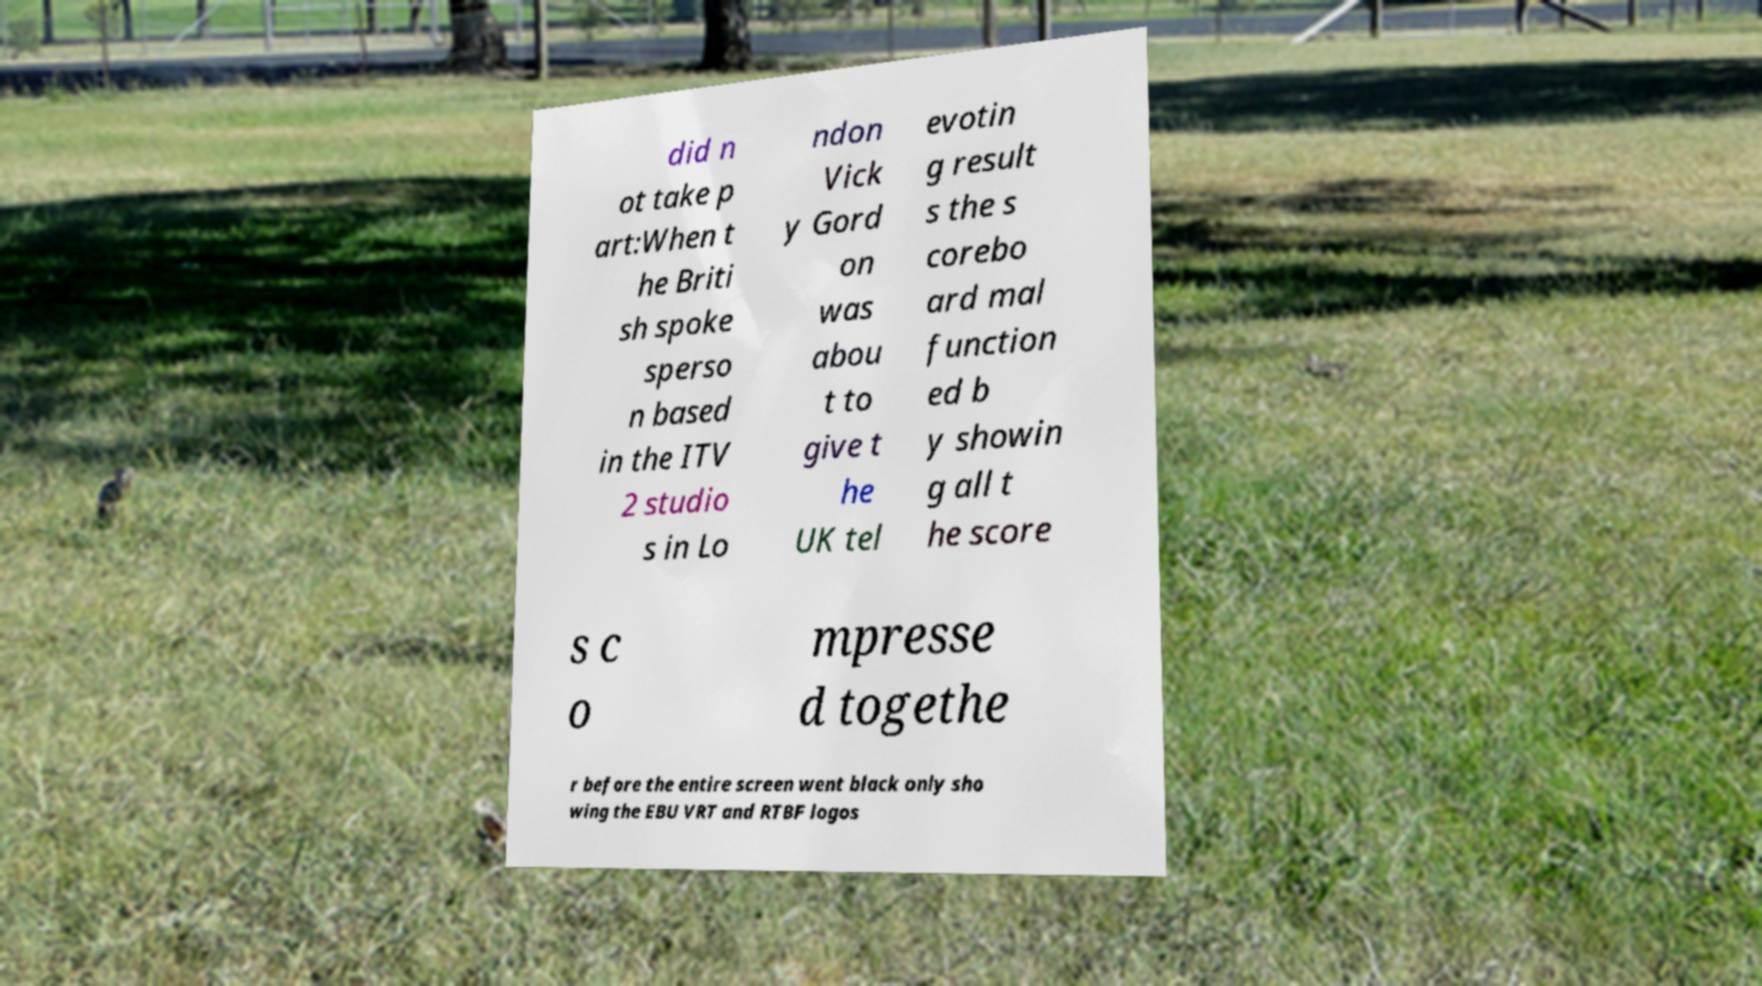Can you read and provide the text displayed in the image?This photo seems to have some interesting text. Can you extract and type it out for me? did n ot take p art:When t he Briti sh spoke sperso n based in the ITV 2 studio s in Lo ndon Vick y Gord on was abou t to give t he UK tel evotin g result s the s corebo ard mal function ed b y showin g all t he score s c o mpresse d togethe r before the entire screen went black only sho wing the EBU VRT and RTBF logos 